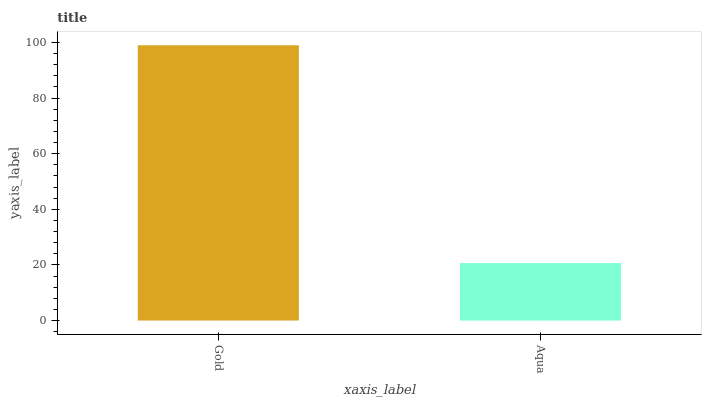Is Aqua the minimum?
Answer yes or no. Yes. Is Gold the maximum?
Answer yes or no. Yes. Is Aqua the maximum?
Answer yes or no. No. Is Gold greater than Aqua?
Answer yes or no. Yes. Is Aqua less than Gold?
Answer yes or no. Yes. Is Aqua greater than Gold?
Answer yes or no. No. Is Gold less than Aqua?
Answer yes or no. No. Is Gold the high median?
Answer yes or no. Yes. Is Aqua the low median?
Answer yes or no. Yes. Is Aqua the high median?
Answer yes or no. No. Is Gold the low median?
Answer yes or no. No. 